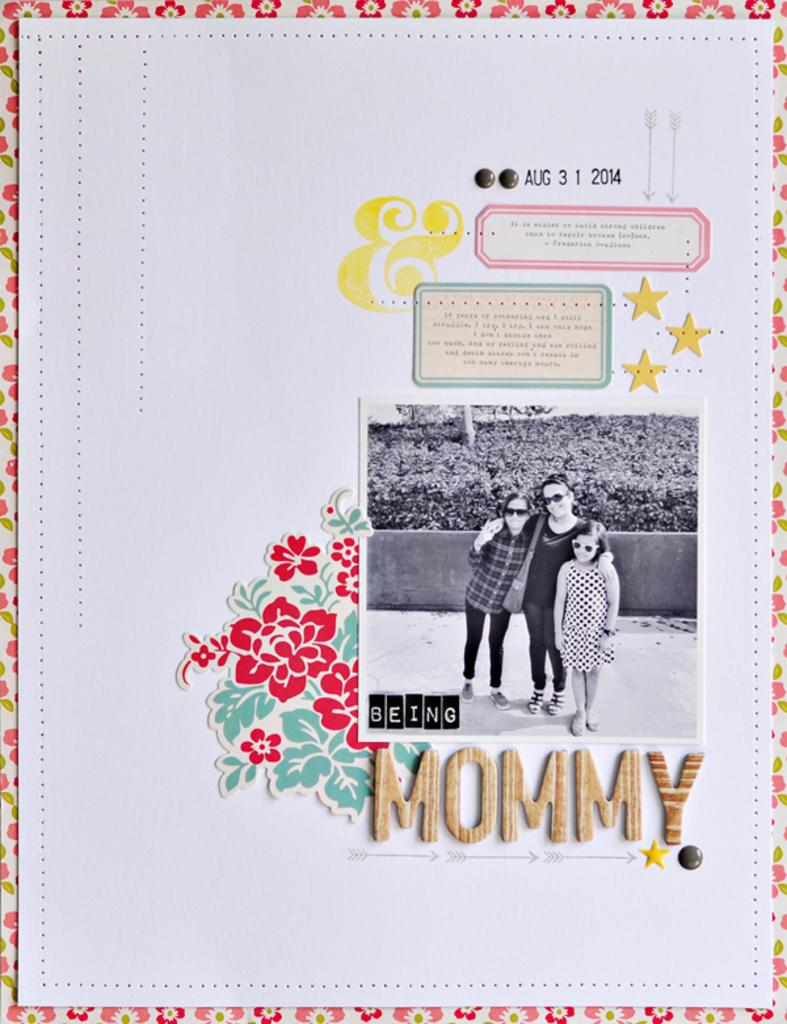What is the primary object in the image? There is a white color paper in the image. What is depicted on the paper? There is a photo of a woman and 2 children on the paper. Are there any written words on the paper? Yes, there are words written on the paper. Are there any decorative elements on the paper? Yes, there are designs on the paper. How many toy bears are visible in the image? There are no toy bears present in the image. What type of clover can be seen growing on the paper? There are no clovers present in the image, as it is a paper with a photo and designs. 